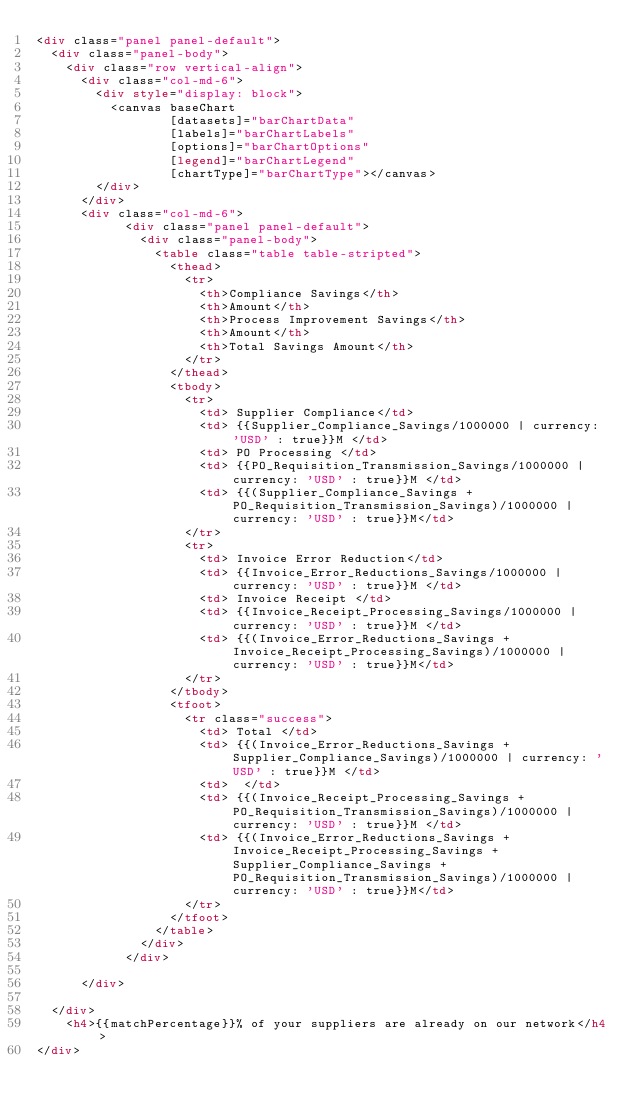<code> <loc_0><loc_0><loc_500><loc_500><_HTML_><div class="panel panel-default">
  <div class="panel-body">
    <div class="row vertical-align">
      <div class="col-md-6">
        <div style="display: block">
          <canvas baseChart
                  [datasets]="barChartData"
                  [labels]="barChartLabels"
                  [options]="barChartOptions"
                  [legend]="barChartLegend"
                  [chartType]="barChartType"></canvas>
        </div>
      </div>
      <div class="col-md-6">
            <div class="panel panel-default">
              <div class="panel-body">
                <table class="table table-stripted">
                  <thead>
                    <tr>
                      <th>Compliance Savings</th>
                      <th>Amount</th>
                      <th>Process Improvement Savings</th>
                      <th>Amount</th>
                      <th>Total Savings Amount</th>
                    </tr>
                  </thead>
                  <tbody>
                    <tr>
                      <td> Supplier Compliance</td>
                      <td> {{Supplier_Compliance_Savings/1000000 | currency: 'USD' : true}}M </td>
                      <td> PO Processing </td>
                      <td> {{PO_Requisition_Transmission_Savings/1000000 | currency: 'USD' : true}}M </td>
                      <td> {{(Supplier_Compliance_Savings + PO_Requisition_Transmission_Savings)/1000000 | currency: 'USD' : true}}M</td>
                    </tr>
                    <tr>
                      <td> Invoice Error Reduction</td>
                      <td> {{Invoice_Error_Reductions_Savings/1000000 | currency: 'USD' : true}}M </td>
                      <td> Invoice Receipt </td>
                      <td> {{Invoice_Receipt_Processing_Savings/1000000 | currency: 'USD' : true}}M </td>
                      <td> {{(Invoice_Error_Reductions_Savings + Invoice_Receipt_Processing_Savings)/1000000 | currency: 'USD' : true}}M</td>
                    </tr>
                  </tbody>
                  <tfoot>
                    <tr class="success">
                      <td> Total </td>
                      <td> {{(Invoice_Error_Reductions_Savings + Supplier_Compliance_Savings)/1000000 | currency: 'USD' : true}}M </td>
                      <td>  </td>
                      <td> {{(Invoice_Receipt_Processing_Savings + PO_Requisition_Transmission_Savings)/1000000 | currency: 'USD' : true}}M </td>
                      <td> {{(Invoice_Error_Reductions_Savings + Invoice_Receipt_Processing_Savings + Supplier_Compliance_Savings + PO_Requisition_Transmission_Savings)/1000000 | currency: 'USD' : true}}M</td>
                    </tr>
                  </tfoot>
                </table>
              </div>
            </div>
            
      </div>
          
  </div>
    <h4>{{matchPercentage}}% of your suppliers are already on our network</h4>
</div>
</code> 